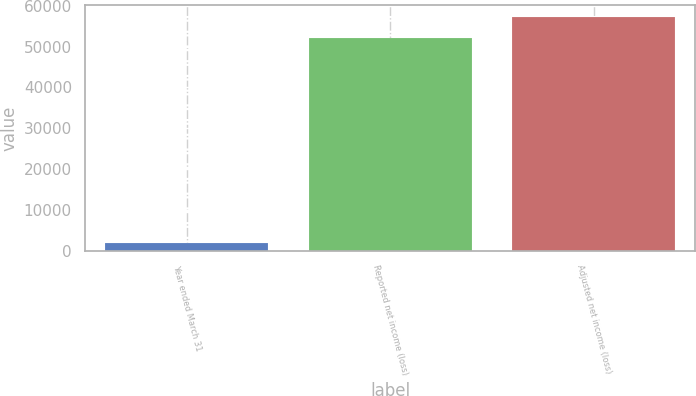<chart> <loc_0><loc_0><loc_500><loc_500><bar_chart><fcel>Year ended March 31<fcel>Reported net income (loss)<fcel>Adjusted net income (loss)<nl><fcel>2002<fcel>52238<fcel>57261.6<nl></chart> 